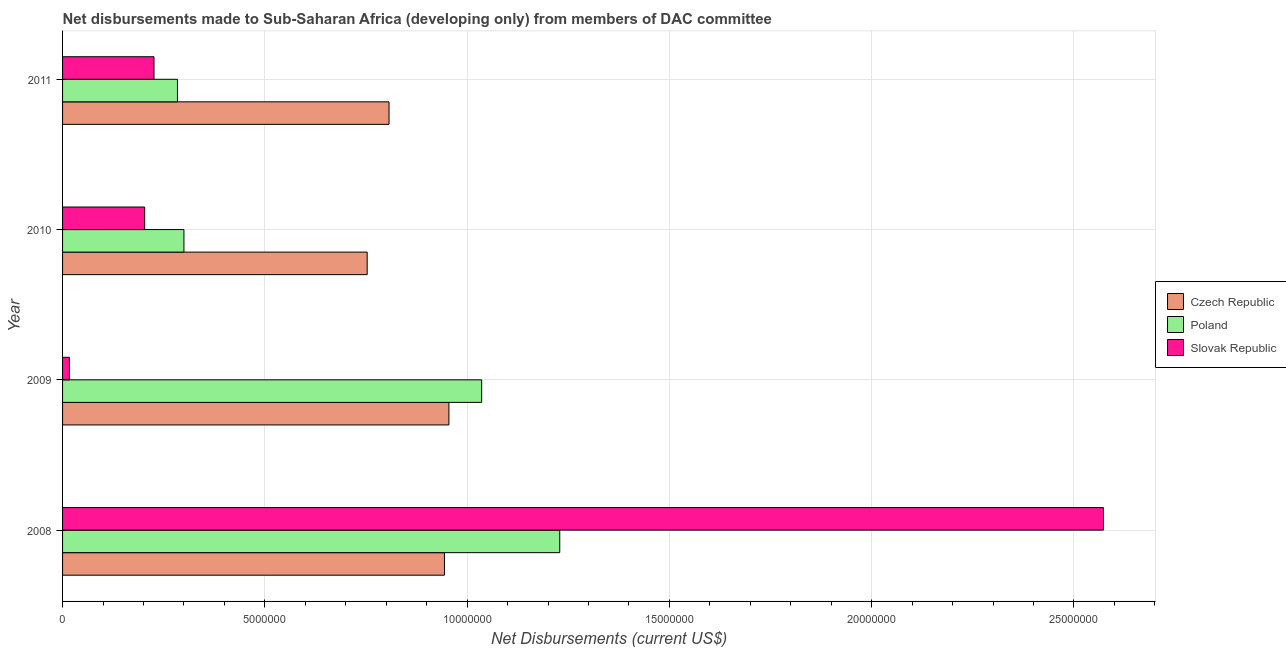How many different coloured bars are there?
Provide a succinct answer. 3. Are the number of bars per tick equal to the number of legend labels?
Your response must be concise. Yes. How many bars are there on the 3rd tick from the top?
Give a very brief answer. 3. In how many cases, is the number of bars for a given year not equal to the number of legend labels?
Your response must be concise. 0. What is the net disbursements made by czech republic in 2009?
Provide a succinct answer. 9.55e+06. Across all years, what is the maximum net disbursements made by poland?
Offer a very short reply. 1.23e+07. Across all years, what is the minimum net disbursements made by slovak republic?
Your answer should be very brief. 1.70e+05. In which year was the net disbursements made by poland maximum?
Offer a terse response. 2008. In which year was the net disbursements made by poland minimum?
Offer a very short reply. 2011. What is the total net disbursements made by poland in the graph?
Ensure brevity in your answer.  2.85e+07. What is the difference between the net disbursements made by slovak republic in 2009 and that in 2010?
Provide a succinct answer. -1.86e+06. What is the difference between the net disbursements made by czech republic in 2010 and the net disbursements made by poland in 2011?
Ensure brevity in your answer.  4.69e+06. What is the average net disbursements made by poland per year?
Provide a succinct answer. 7.12e+06. In the year 2009, what is the difference between the net disbursements made by slovak republic and net disbursements made by poland?
Your answer should be very brief. -1.02e+07. What is the ratio of the net disbursements made by poland in 2009 to that in 2011?
Ensure brevity in your answer.  3.65. What is the difference between the highest and the second highest net disbursements made by czech republic?
Offer a very short reply. 1.10e+05. What is the difference between the highest and the lowest net disbursements made by czech republic?
Your response must be concise. 2.02e+06. In how many years, is the net disbursements made by poland greater than the average net disbursements made by poland taken over all years?
Make the answer very short. 2. Is the sum of the net disbursements made by poland in 2010 and 2011 greater than the maximum net disbursements made by slovak republic across all years?
Your response must be concise. No. What does the 2nd bar from the top in 2011 represents?
Give a very brief answer. Poland. What does the 1st bar from the bottom in 2009 represents?
Provide a short and direct response. Czech Republic. Where does the legend appear in the graph?
Your answer should be compact. Center right. How are the legend labels stacked?
Ensure brevity in your answer.  Vertical. What is the title of the graph?
Your answer should be very brief. Net disbursements made to Sub-Saharan Africa (developing only) from members of DAC committee. What is the label or title of the X-axis?
Offer a terse response. Net Disbursements (current US$). What is the Net Disbursements (current US$) of Czech Republic in 2008?
Offer a terse response. 9.44e+06. What is the Net Disbursements (current US$) in Poland in 2008?
Ensure brevity in your answer.  1.23e+07. What is the Net Disbursements (current US$) of Slovak Republic in 2008?
Your answer should be compact. 2.57e+07. What is the Net Disbursements (current US$) of Czech Republic in 2009?
Your answer should be compact. 9.55e+06. What is the Net Disbursements (current US$) of Poland in 2009?
Provide a succinct answer. 1.04e+07. What is the Net Disbursements (current US$) of Czech Republic in 2010?
Keep it short and to the point. 7.53e+06. What is the Net Disbursements (current US$) of Poland in 2010?
Give a very brief answer. 3.00e+06. What is the Net Disbursements (current US$) in Slovak Republic in 2010?
Your answer should be compact. 2.03e+06. What is the Net Disbursements (current US$) in Czech Republic in 2011?
Keep it short and to the point. 8.07e+06. What is the Net Disbursements (current US$) of Poland in 2011?
Provide a short and direct response. 2.84e+06. What is the Net Disbursements (current US$) in Slovak Republic in 2011?
Keep it short and to the point. 2.26e+06. Across all years, what is the maximum Net Disbursements (current US$) of Czech Republic?
Provide a succinct answer. 9.55e+06. Across all years, what is the maximum Net Disbursements (current US$) in Poland?
Offer a very short reply. 1.23e+07. Across all years, what is the maximum Net Disbursements (current US$) in Slovak Republic?
Your answer should be very brief. 2.57e+07. Across all years, what is the minimum Net Disbursements (current US$) of Czech Republic?
Provide a succinct answer. 7.53e+06. Across all years, what is the minimum Net Disbursements (current US$) in Poland?
Give a very brief answer. 2.84e+06. What is the total Net Disbursements (current US$) of Czech Republic in the graph?
Provide a short and direct response. 3.46e+07. What is the total Net Disbursements (current US$) of Poland in the graph?
Make the answer very short. 2.85e+07. What is the total Net Disbursements (current US$) of Slovak Republic in the graph?
Your response must be concise. 3.02e+07. What is the difference between the Net Disbursements (current US$) of Poland in 2008 and that in 2009?
Offer a terse response. 1.93e+06. What is the difference between the Net Disbursements (current US$) in Slovak Republic in 2008 and that in 2009?
Ensure brevity in your answer.  2.56e+07. What is the difference between the Net Disbursements (current US$) of Czech Republic in 2008 and that in 2010?
Your answer should be very brief. 1.91e+06. What is the difference between the Net Disbursements (current US$) of Poland in 2008 and that in 2010?
Your answer should be compact. 9.29e+06. What is the difference between the Net Disbursements (current US$) in Slovak Republic in 2008 and that in 2010?
Provide a short and direct response. 2.37e+07. What is the difference between the Net Disbursements (current US$) of Czech Republic in 2008 and that in 2011?
Make the answer very short. 1.37e+06. What is the difference between the Net Disbursements (current US$) in Poland in 2008 and that in 2011?
Your answer should be compact. 9.45e+06. What is the difference between the Net Disbursements (current US$) in Slovak Republic in 2008 and that in 2011?
Your answer should be very brief. 2.35e+07. What is the difference between the Net Disbursements (current US$) of Czech Republic in 2009 and that in 2010?
Provide a succinct answer. 2.02e+06. What is the difference between the Net Disbursements (current US$) in Poland in 2009 and that in 2010?
Offer a terse response. 7.36e+06. What is the difference between the Net Disbursements (current US$) of Slovak Republic in 2009 and that in 2010?
Give a very brief answer. -1.86e+06. What is the difference between the Net Disbursements (current US$) of Czech Republic in 2009 and that in 2011?
Your answer should be compact. 1.48e+06. What is the difference between the Net Disbursements (current US$) in Poland in 2009 and that in 2011?
Your answer should be very brief. 7.52e+06. What is the difference between the Net Disbursements (current US$) in Slovak Republic in 2009 and that in 2011?
Keep it short and to the point. -2.09e+06. What is the difference between the Net Disbursements (current US$) in Czech Republic in 2010 and that in 2011?
Offer a very short reply. -5.40e+05. What is the difference between the Net Disbursements (current US$) in Czech Republic in 2008 and the Net Disbursements (current US$) in Poland in 2009?
Your response must be concise. -9.20e+05. What is the difference between the Net Disbursements (current US$) in Czech Republic in 2008 and the Net Disbursements (current US$) in Slovak Republic in 2009?
Your response must be concise. 9.27e+06. What is the difference between the Net Disbursements (current US$) of Poland in 2008 and the Net Disbursements (current US$) of Slovak Republic in 2009?
Your response must be concise. 1.21e+07. What is the difference between the Net Disbursements (current US$) in Czech Republic in 2008 and the Net Disbursements (current US$) in Poland in 2010?
Your answer should be compact. 6.44e+06. What is the difference between the Net Disbursements (current US$) of Czech Republic in 2008 and the Net Disbursements (current US$) of Slovak Republic in 2010?
Provide a short and direct response. 7.41e+06. What is the difference between the Net Disbursements (current US$) of Poland in 2008 and the Net Disbursements (current US$) of Slovak Republic in 2010?
Keep it short and to the point. 1.03e+07. What is the difference between the Net Disbursements (current US$) in Czech Republic in 2008 and the Net Disbursements (current US$) in Poland in 2011?
Offer a terse response. 6.60e+06. What is the difference between the Net Disbursements (current US$) in Czech Republic in 2008 and the Net Disbursements (current US$) in Slovak Republic in 2011?
Offer a terse response. 7.18e+06. What is the difference between the Net Disbursements (current US$) in Poland in 2008 and the Net Disbursements (current US$) in Slovak Republic in 2011?
Your answer should be compact. 1.00e+07. What is the difference between the Net Disbursements (current US$) of Czech Republic in 2009 and the Net Disbursements (current US$) of Poland in 2010?
Provide a succinct answer. 6.55e+06. What is the difference between the Net Disbursements (current US$) in Czech Republic in 2009 and the Net Disbursements (current US$) in Slovak Republic in 2010?
Keep it short and to the point. 7.52e+06. What is the difference between the Net Disbursements (current US$) in Poland in 2009 and the Net Disbursements (current US$) in Slovak Republic in 2010?
Give a very brief answer. 8.33e+06. What is the difference between the Net Disbursements (current US$) of Czech Republic in 2009 and the Net Disbursements (current US$) of Poland in 2011?
Give a very brief answer. 6.71e+06. What is the difference between the Net Disbursements (current US$) of Czech Republic in 2009 and the Net Disbursements (current US$) of Slovak Republic in 2011?
Keep it short and to the point. 7.29e+06. What is the difference between the Net Disbursements (current US$) of Poland in 2009 and the Net Disbursements (current US$) of Slovak Republic in 2011?
Ensure brevity in your answer.  8.10e+06. What is the difference between the Net Disbursements (current US$) in Czech Republic in 2010 and the Net Disbursements (current US$) in Poland in 2011?
Give a very brief answer. 4.69e+06. What is the difference between the Net Disbursements (current US$) of Czech Republic in 2010 and the Net Disbursements (current US$) of Slovak Republic in 2011?
Give a very brief answer. 5.27e+06. What is the difference between the Net Disbursements (current US$) of Poland in 2010 and the Net Disbursements (current US$) of Slovak Republic in 2011?
Provide a succinct answer. 7.40e+05. What is the average Net Disbursements (current US$) in Czech Republic per year?
Your answer should be compact. 8.65e+06. What is the average Net Disbursements (current US$) in Poland per year?
Ensure brevity in your answer.  7.12e+06. What is the average Net Disbursements (current US$) of Slovak Republic per year?
Provide a succinct answer. 7.55e+06. In the year 2008, what is the difference between the Net Disbursements (current US$) of Czech Republic and Net Disbursements (current US$) of Poland?
Provide a short and direct response. -2.85e+06. In the year 2008, what is the difference between the Net Disbursements (current US$) of Czech Republic and Net Disbursements (current US$) of Slovak Republic?
Provide a succinct answer. -1.63e+07. In the year 2008, what is the difference between the Net Disbursements (current US$) of Poland and Net Disbursements (current US$) of Slovak Republic?
Offer a terse response. -1.34e+07. In the year 2009, what is the difference between the Net Disbursements (current US$) in Czech Republic and Net Disbursements (current US$) in Poland?
Your answer should be very brief. -8.10e+05. In the year 2009, what is the difference between the Net Disbursements (current US$) in Czech Republic and Net Disbursements (current US$) in Slovak Republic?
Keep it short and to the point. 9.38e+06. In the year 2009, what is the difference between the Net Disbursements (current US$) of Poland and Net Disbursements (current US$) of Slovak Republic?
Offer a terse response. 1.02e+07. In the year 2010, what is the difference between the Net Disbursements (current US$) in Czech Republic and Net Disbursements (current US$) in Poland?
Your answer should be very brief. 4.53e+06. In the year 2010, what is the difference between the Net Disbursements (current US$) of Czech Republic and Net Disbursements (current US$) of Slovak Republic?
Give a very brief answer. 5.50e+06. In the year 2010, what is the difference between the Net Disbursements (current US$) in Poland and Net Disbursements (current US$) in Slovak Republic?
Provide a short and direct response. 9.70e+05. In the year 2011, what is the difference between the Net Disbursements (current US$) of Czech Republic and Net Disbursements (current US$) of Poland?
Keep it short and to the point. 5.23e+06. In the year 2011, what is the difference between the Net Disbursements (current US$) of Czech Republic and Net Disbursements (current US$) of Slovak Republic?
Offer a terse response. 5.81e+06. In the year 2011, what is the difference between the Net Disbursements (current US$) of Poland and Net Disbursements (current US$) of Slovak Republic?
Your answer should be very brief. 5.80e+05. What is the ratio of the Net Disbursements (current US$) in Czech Republic in 2008 to that in 2009?
Your response must be concise. 0.99. What is the ratio of the Net Disbursements (current US$) of Poland in 2008 to that in 2009?
Ensure brevity in your answer.  1.19. What is the ratio of the Net Disbursements (current US$) of Slovak Republic in 2008 to that in 2009?
Your answer should be very brief. 151.35. What is the ratio of the Net Disbursements (current US$) in Czech Republic in 2008 to that in 2010?
Give a very brief answer. 1.25. What is the ratio of the Net Disbursements (current US$) of Poland in 2008 to that in 2010?
Your answer should be very brief. 4.1. What is the ratio of the Net Disbursements (current US$) of Slovak Republic in 2008 to that in 2010?
Your answer should be compact. 12.67. What is the ratio of the Net Disbursements (current US$) of Czech Republic in 2008 to that in 2011?
Provide a short and direct response. 1.17. What is the ratio of the Net Disbursements (current US$) of Poland in 2008 to that in 2011?
Provide a succinct answer. 4.33. What is the ratio of the Net Disbursements (current US$) in Slovak Republic in 2008 to that in 2011?
Keep it short and to the point. 11.38. What is the ratio of the Net Disbursements (current US$) of Czech Republic in 2009 to that in 2010?
Provide a short and direct response. 1.27. What is the ratio of the Net Disbursements (current US$) of Poland in 2009 to that in 2010?
Offer a terse response. 3.45. What is the ratio of the Net Disbursements (current US$) of Slovak Republic in 2009 to that in 2010?
Provide a succinct answer. 0.08. What is the ratio of the Net Disbursements (current US$) of Czech Republic in 2009 to that in 2011?
Provide a short and direct response. 1.18. What is the ratio of the Net Disbursements (current US$) in Poland in 2009 to that in 2011?
Give a very brief answer. 3.65. What is the ratio of the Net Disbursements (current US$) in Slovak Republic in 2009 to that in 2011?
Your response must be concise. 0.08. What is the ratio of the Net Disbursements (current US$) of Czech Republic in 2010 to that in 2011?
Your answer should be very brief. 0.93. What is the ratio of the Net Disbursements (current US$) of Poland in 2010 to that in 2011?
Your answer should be very brief. 1.06. What is the ratio of the Net Disbursements (current US$) in Slovak Republic in 2010 to that in 2011?
Give a very brief answer. 0.9. What is the difference between the highest and the second highest Net Disbursements (current US$) in Poland?
Provide a short and direct response. 1.93e+06. What is the difference between the highest and the second highest Net Disbursements (current US$) in Slovak Republic?
Provide a succinct answer. 2.35e+07. What is the difference between the highest and the lowest Net Disbursements (current US$) of Czech Republic?
Keep it short and to the point. 2.02e+06. What is the difference between the highest and the lowest Net Disbursements (current US$) in Poland?
Offer a very short reply. 9.45e+06. What is the difference between the highest and the lowest Net Disbursements (current US$) in Slovak Republic?
Keep it short and to the point. 2.56e+07. 